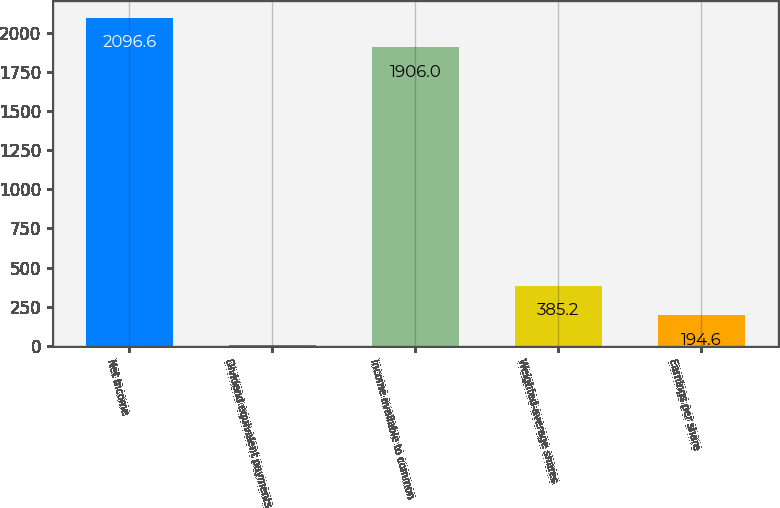Convert chart. <chart><loc_0><loc_0><loc_500><loc_500><bar_chart><fcel>Net income<fcel>Dividend equivalent payments<fcel>Income available to common<fcel>Weighted-average shares<fcel>Earnings per share<nl><fcel>2096.6<fcel>4<fcel>1906<fcel>385.2<fcel>194.6<nl></chart> 